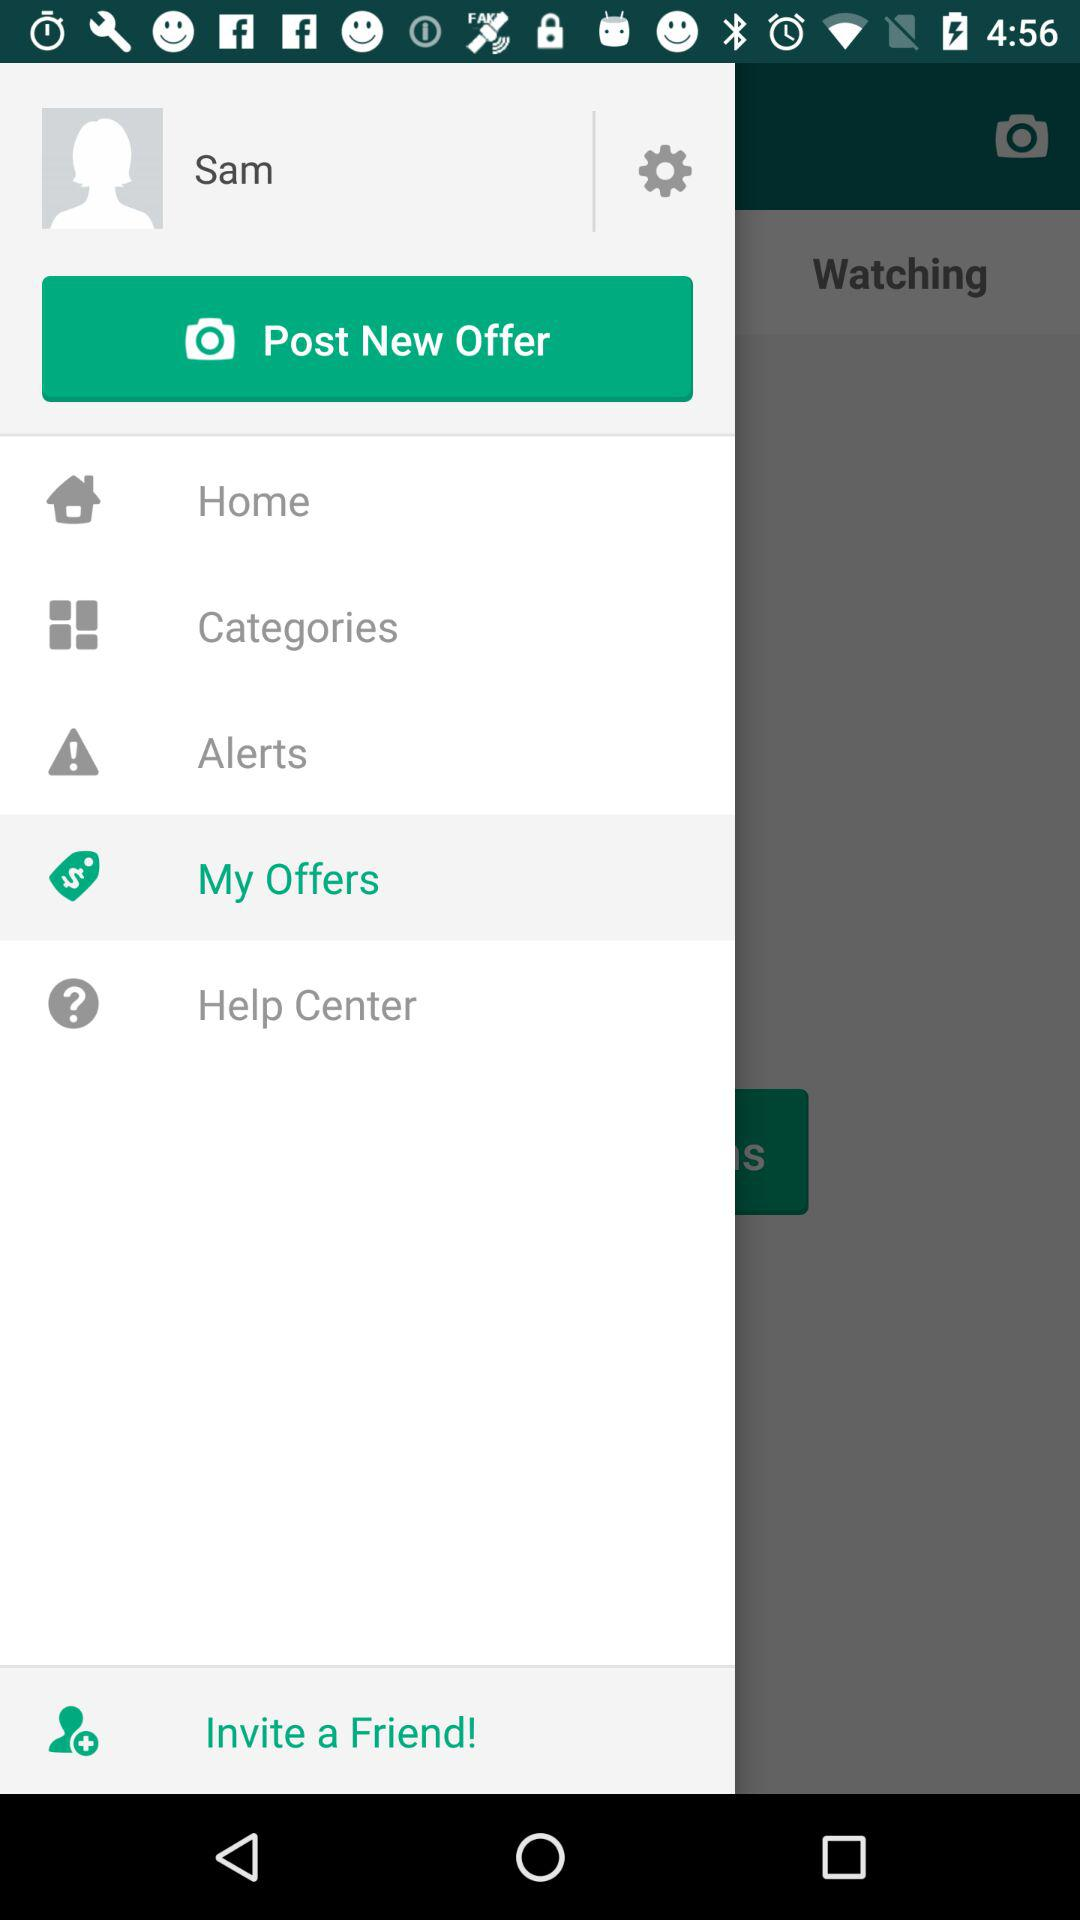Which option has been selected? The selected option is "My Offers". 